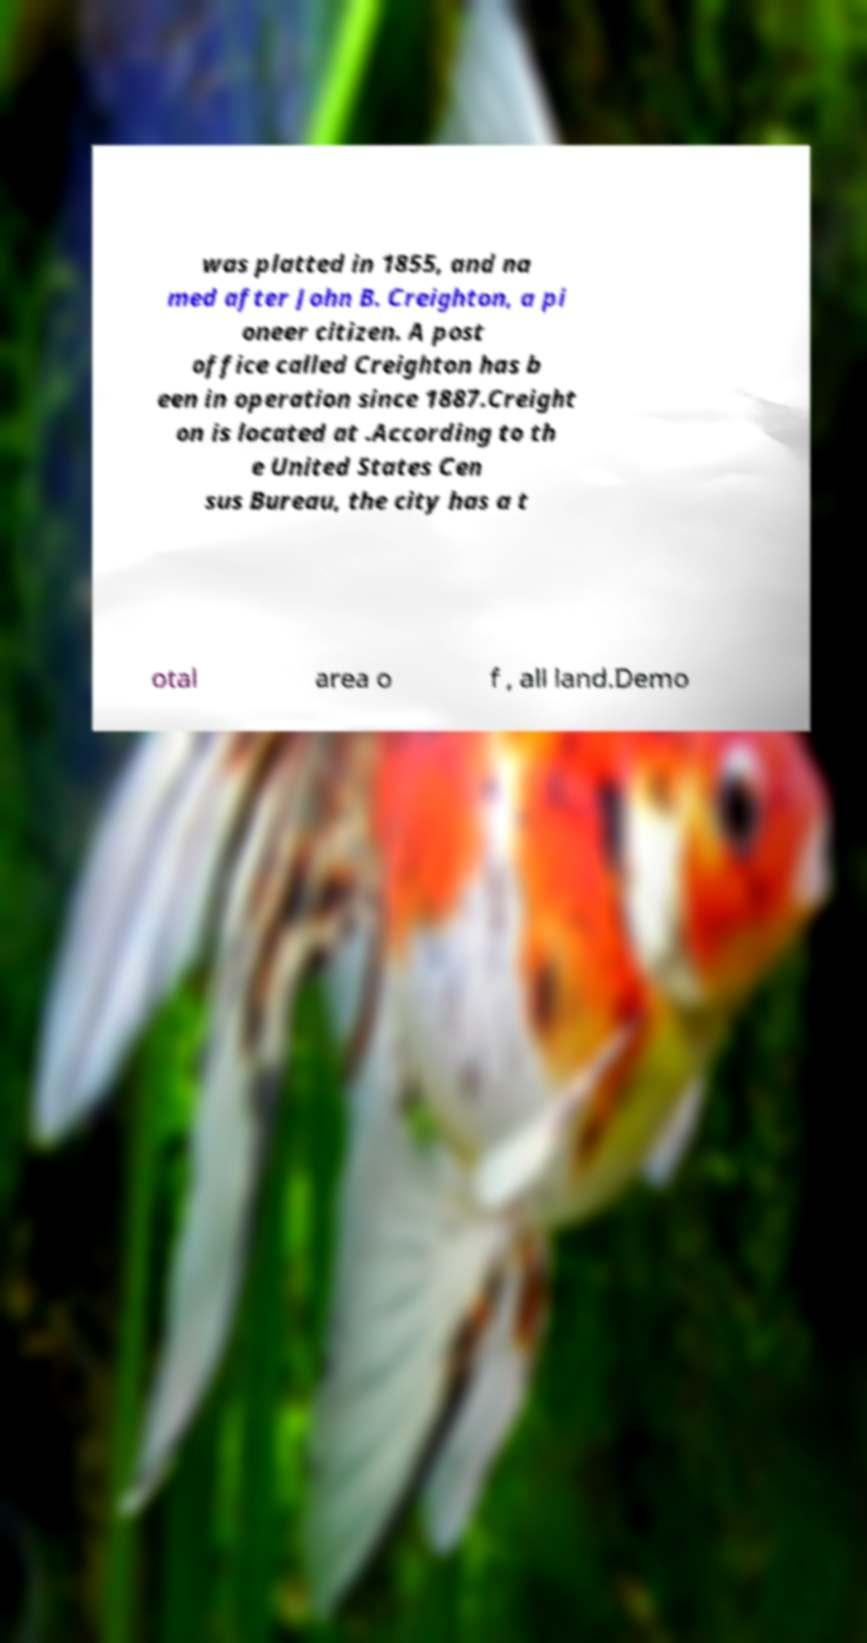Could you extract and type out the text from this image? was platted in 1855, and na med after John B. Creighton, a pi oneer citizen. A post office called Creighton has b een in operation since 1887.Creight on is located at .According to th e United States Cen sus Bureau, the city has a t otal area o f , all land.Demo 